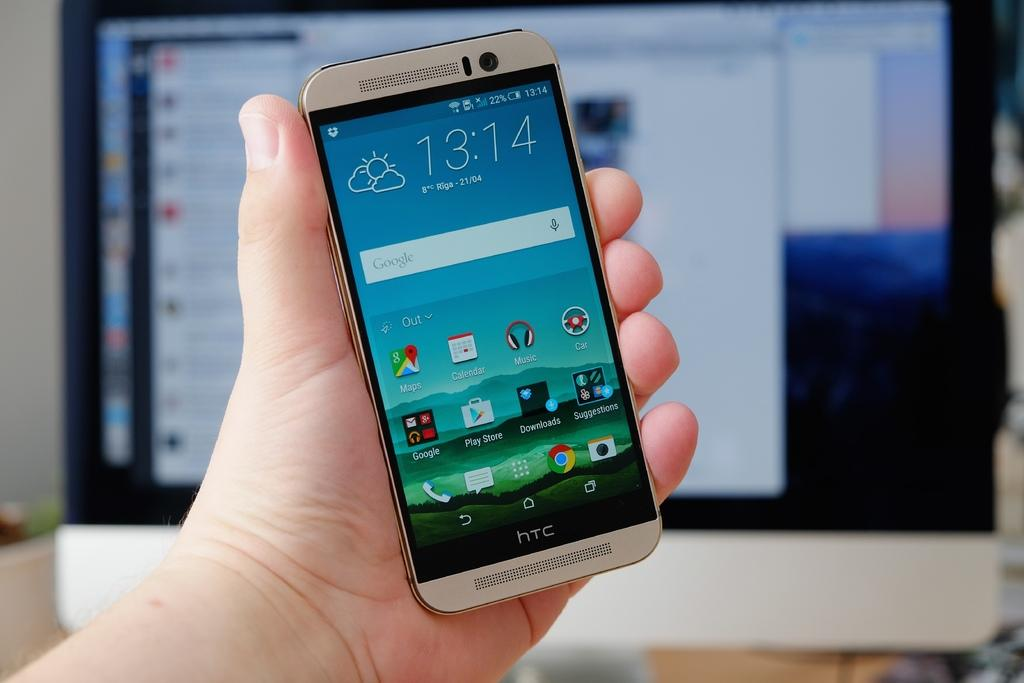<image>
Give a short and clear explanation of the subsequent image. Someone is showing a smartphone from HTC that has some applications such as calendar and maps. 